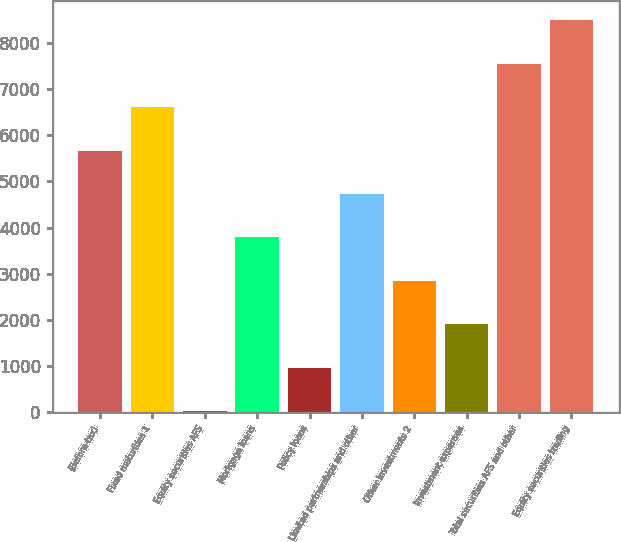Convert chart. <chart><loc_0><loc_0><loc_500><loc_500><bar_chart><fcel>(Before-tax)<fcel>Fixed maturities 1<fcel>Equity securities AFS<fcel>Mortgage loans<fcel>Policy loans<fcel>Limited partnerships and other<fcel>Other investments 2<fcel>Investment expenses<fcel>Total securities AFS and other<fcel>Equity securities trading<nl><fcel>5665.8<fcel>6605.1<fcel>30<fcel>3787.2<fcel>969.3<fcel>4726.5<fcel>2847.9<fcel>1908.6<fcel>7544.4<fcel>8483.7<nl></chart> 